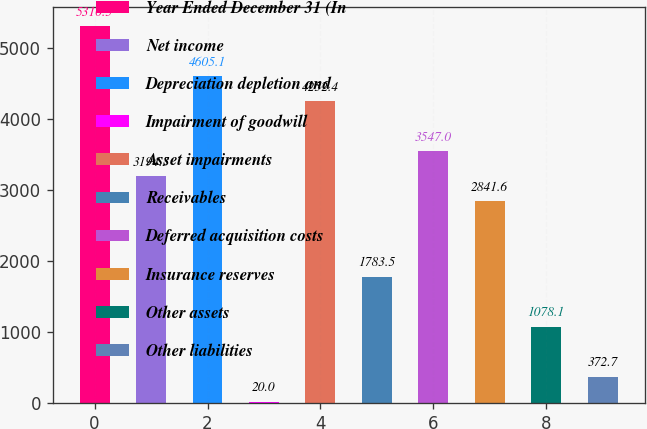Convert chart. <chart><loc_0><loc_0><loc_500><loc_500><bar_chart><fcel>Year Ended December 31 (In<fcel>Net income<fcel>Depreciation depletion and<fcel>Impairment of goodwill<fcel>Asset impairments<fcel>Receivables<fcel>Deferred acquisition costs<fcel>Insurance reserves<fcel>Other assets<fcel>Other liabilities<nl><fcel>5310.5<fcel>3194.3<fcel>4605.1<fcel>20<fcel>4252.4<fcel>1783.5<fcel>3547<fcel>2841.6<fcel>1078.1<fcel>372.7<nl></chart> 